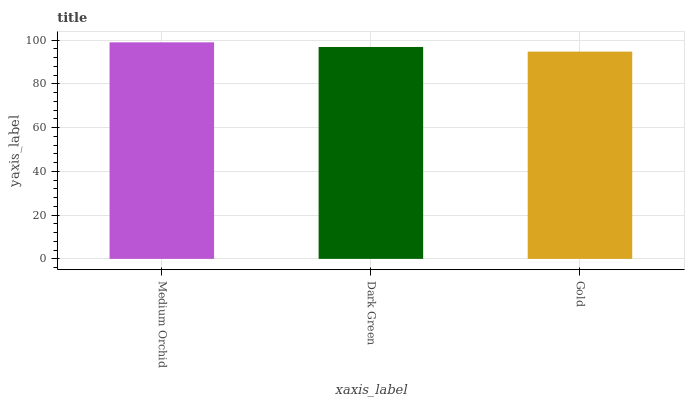Is Gold the minimum?
Answer yes or no. Yes. Is Medium Orchid the maximum?
Answer yes or no. Yes. Is Dark Green the minimum?
Answer yes or no. No. Is Dark Green the maximum?
Answer yes or no. No. Is Medium Orchid greater than Dark Green?
Answer yes or no. Yes. Is Dark Green less than Medium Orchid?
Answer yes or no. Yes. Is Dark Green greater than Medium Orchid?
Answer yes or no. No. Is Medium Orchid less than Dark Green?
Answer yes or no. No. Is Dark Green the high median?
Answer yes or no. Yes. Is Dark Green the low median?
Answer yes or no. Yes. Is Medium Orchid the high median?
Answer yes or no. No. Is Gold the low median?
Answer yes or no. No. 